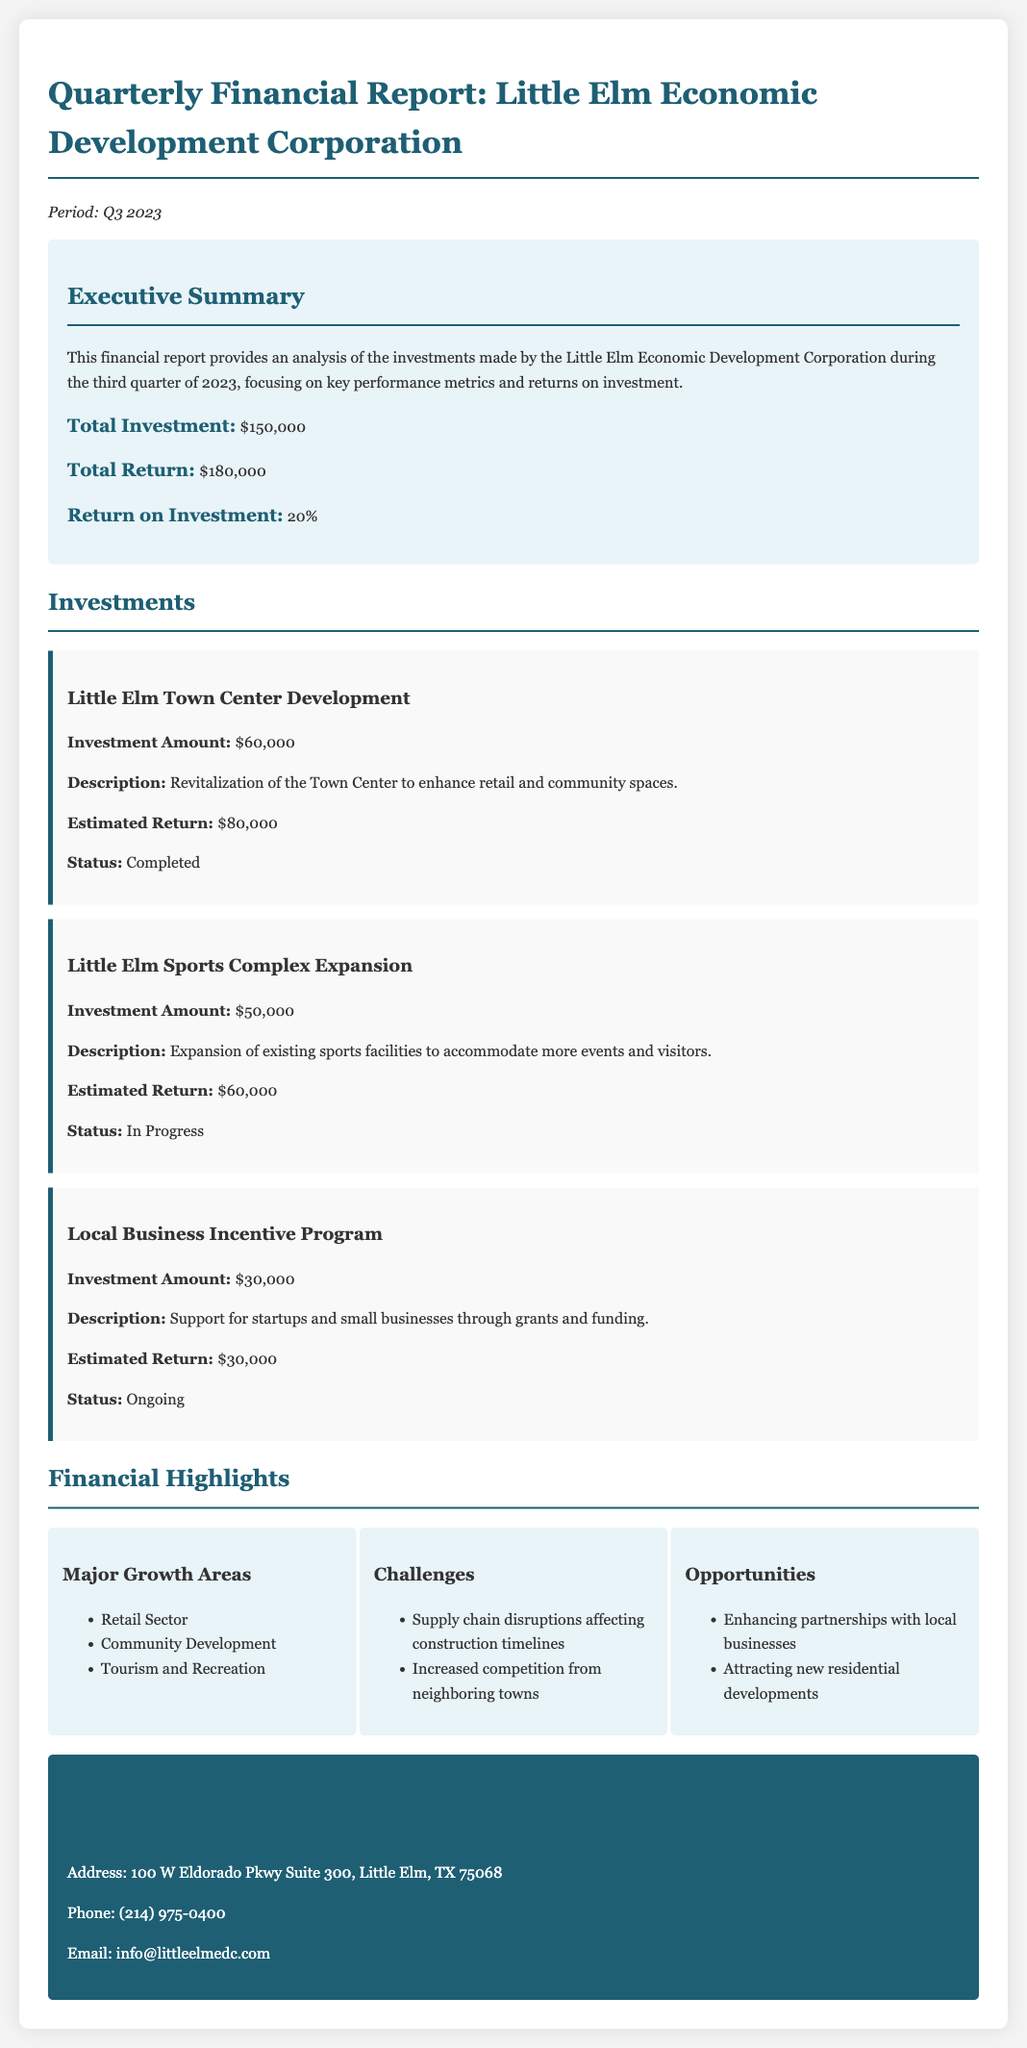what was the total investment made by the Little Elm Economic Development Corporation? The total investment is specified in the Executive Summary of the document.
Answer: $150,000 what was the total return from the investments? The total return reflects the earnings generated from the investments in the Executive Summary.
Answer: $180,000 what is the return on investment percentage? This percentage is calculated and presented in the Executive Summary of the document.
Answer: 20% how much was invested in the Little Elm Town Center Development? The investment amount is listed under the Investments section for this project.
Answer: $60,000 what is the status of the Little Elm Sports Complex Expansion? The status is indicated in the Investments section, specifically for this expansion project.
Answer: In Progress what is one major growth area mentioned in the financial highlights? The document lists growth areas in the Financial Highlights section.
Answer: Retail Sector what challenge is identified in the report? One of the challenges is highlighted in the Financial Highlights section of the document.
Answer: Supply chain disruptions affecting construction timelines what opportunity is presented for the future? The report mentions opportunities in the Financial Highlights section.
Answer: Enhancing partnerships with local businesses how much was allocated for the Local Business Incentive Program? The allocated budget for this program is detailed in the Investments section.
Answer: $30,000 